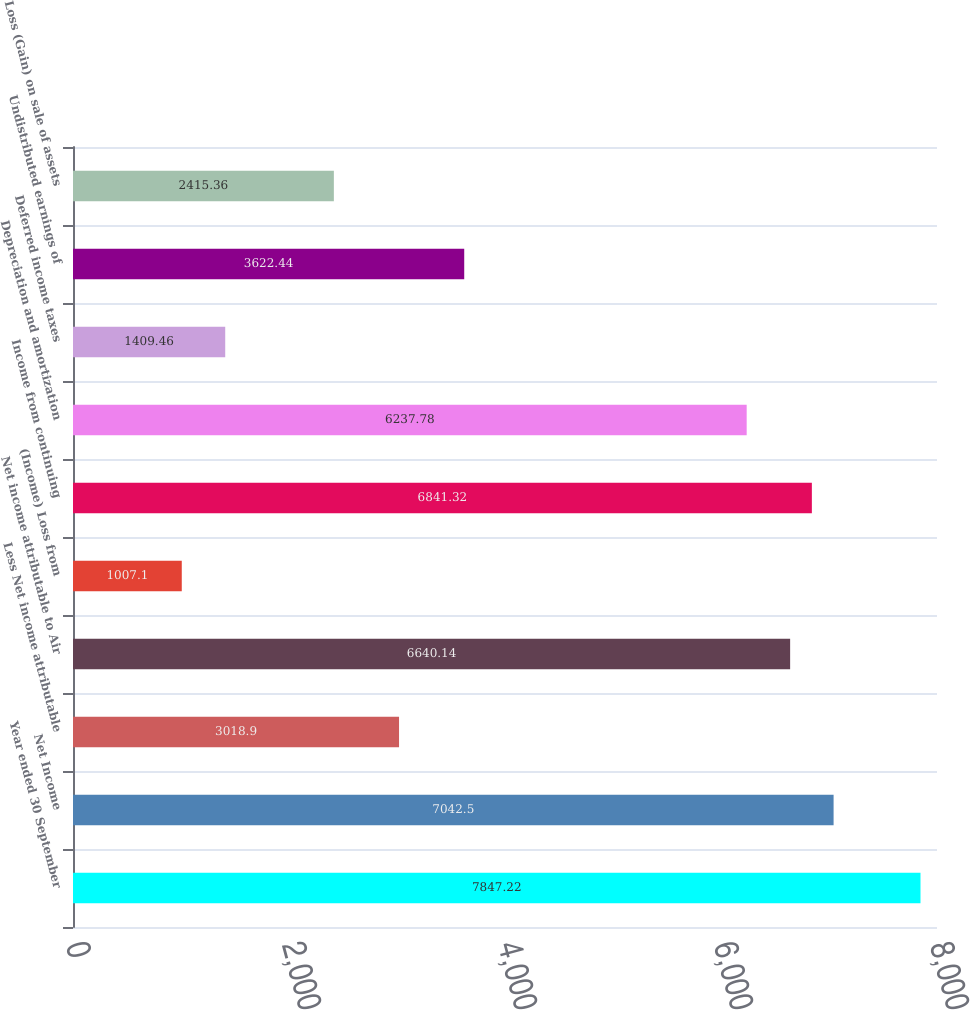<chart> <loc_0><loc_0><loc_500><loc_500><bar_chart><fcel>Year ended 30 September<fcel>Net Income<fcel>Less Net income attributable<fcel>Net income attributable to Air<fcel>(Income) Loss from<fcel>Income from continuing<fcel>Depreciation and amortization<fcel>Deferred income taxes<fcel>Undistributed earnings of<fcel>Loss (Gain) on sale of assets<nl><fcel>7847.22<fcel>7042.5<fcel>3018.9<fcel>6640.14<fcel>1007.1<fcel>6841.32<fcel>6237.78<fcel>1409.46<fcel>3622.44<fcel>2415.36<nl></chart> 